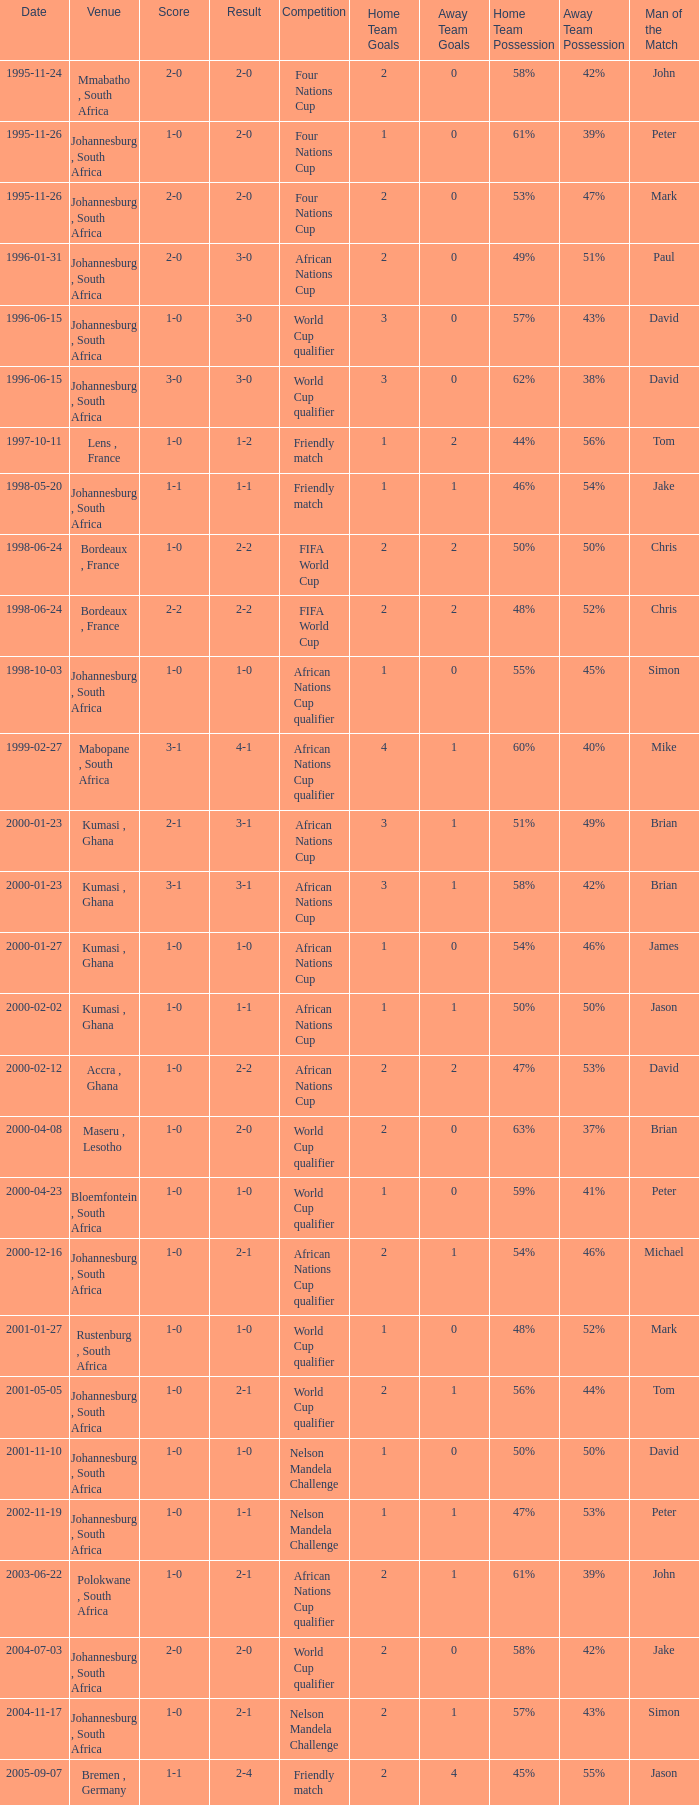What is the Venue of the Competition on 2001-05-05? Johannesburg , South Africa. 